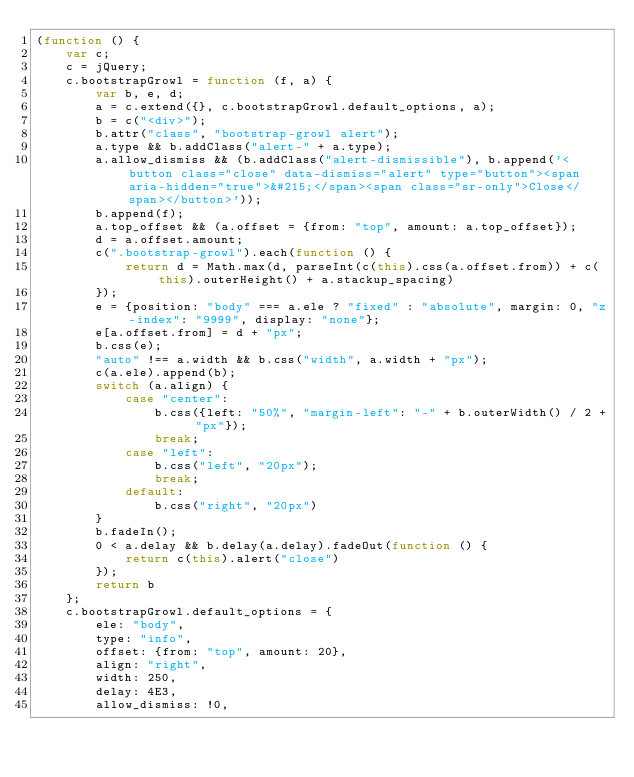Convert code to text. <code><loc_0><loc_0><loc_500><loc_500><_JavaScript_>(function () {
    var c;
    c = jQuery;
    c.bootstrapGrowl = function (f, a) {
        var b, e, d;
        a = c.extend({}, c.bootstrapGrowl.default_options, a);
        b = c("<div>");
        b.attr("class", "bootstrap-growl alert");
        a.type && b.addClass("alert-" + a.type);
        a.allow_dismiss && (b.addClass("alert-dismissible"), b.append('<button class="close" data-dismiss="alert" type="button"><span aria-hidden="true">&#215;</span><span class="sr-only">Close</span></button>'));
        b.append(f);
        a.top_offset && (a.offset = {from: "top", amount: a.top_offset});
        d = a.offset.amount;
        c(".bootstrap-growl").each(function () {
            return d = Math.max(d, parseInt(c(this).css(a.offset.from)) + c(this).outerHeight() + a.stackup_spacing)
        });
        e = {position: "body" === a.ele ? "fixed" : "absolute", margin: 0, "z-index": "9999", display: "none"};
        e[a.offset.from] = d + "px";
        b.css(e);
        "auto" !== a.width && b.css("width", a.width + "px");
        c(a.ele).append(b);
        switch (a.align) {
            case "center":
                b.css({left: "50%", "margin-left": "-" + b.outerWidth() / 2 + "px"});
                break;
            case "left":
                b.css("left", "20px");
                break;
            default:
                b.css("right", "20px")
        }
        b.fadeIn();
        0 < a.delay && b.delay(a.delay).fadeOut(function () {
            return c(this).alert("close")
        });
        return b
    };
    c.bootstrapGrowl.default_options = {
        ele: "body",
        type: "info",
        offset: {from: "top", amount: 20},
        align: "right",
        width: 250,
        delay: 4E3,
        allow_dismiss: !0,</code> 